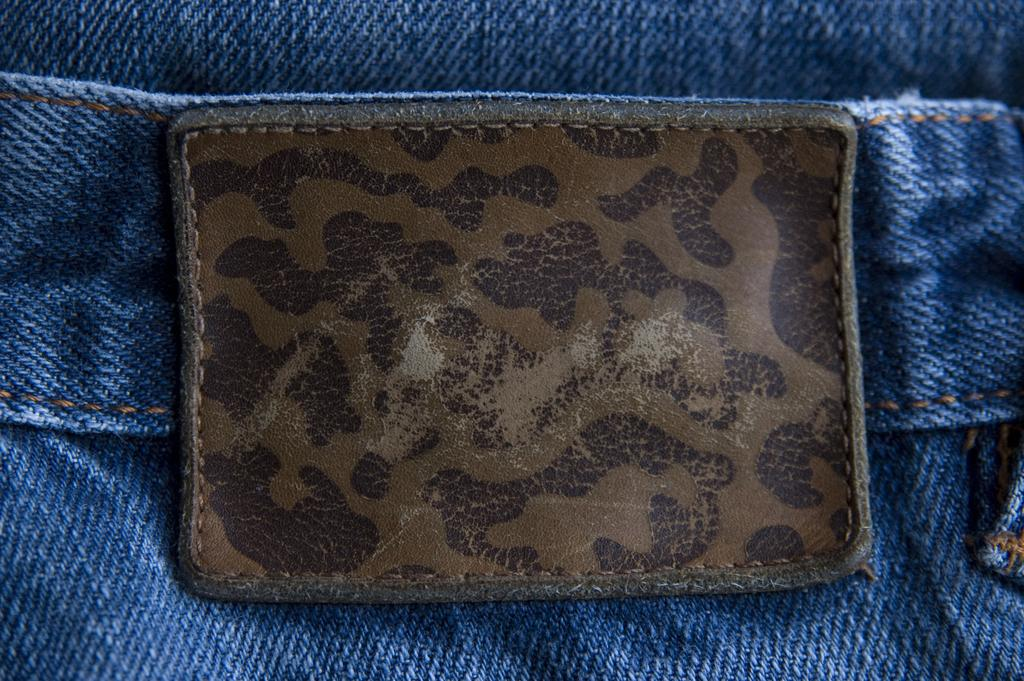What material is the piece in the image made of? The piece in the image is made of leather. Where is the leather piece located? The leather piece is on a jeans pant. What type of cub can be seen playing with balls in the image? There is no cub or balls present in the image; it features a leather piece on a jeans pant. 